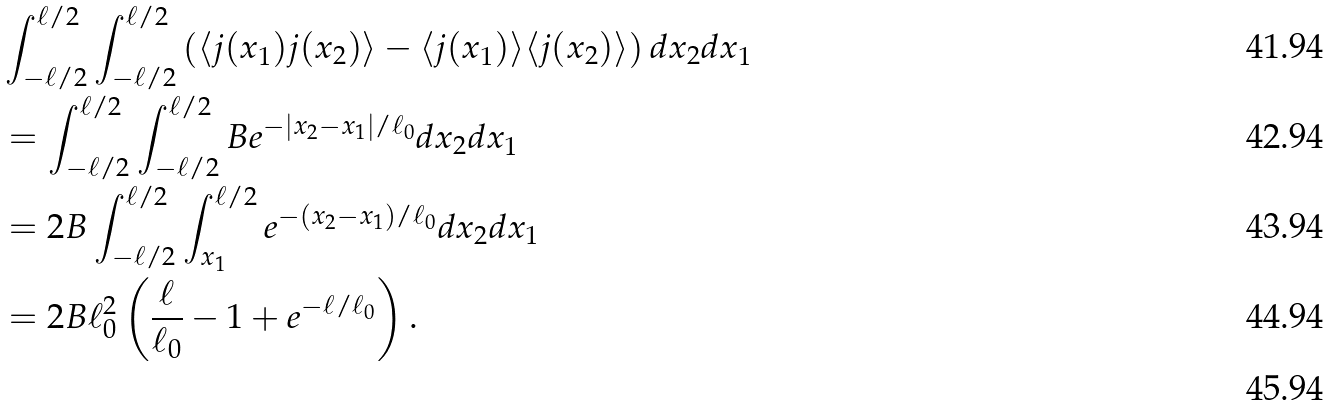Convert formula to latex. <formula><loc_0><loc_0><loc_500><loc_500>& \int _ { - \ell / 2 } ^ { \ell / 2 } \int _ { - \ell / 2 } ^ { \ell / 2 } \left ( \langle j ( x _ { 1 } ) j ( x _ { 2 } ) \rangle - \langle j ( x _ { 1 } ) \rangle \langle j ( x _ { 2 } ) \rangle \right ) d x _ { 2 } d x _ { 1 } \\ & = \int _ { - \ell / 2 } ^ { \ell / 2 } \int _ { - \ell / 2 } ^ { \ell / 2 } B e ^ { - | x _ { 2 } - x _ { 1 } | / { \ell _ { 0 } } } d x _ { 2 } d x _ { 1 } \\ & = 2 B \int _ { - \ell / 2 } ^ { \ell / 2 } \int _ { x _ { 1 } } ^ { \ell / 2 } e ^ { - ( x _ { 2 } - x _ { 1 } ) / { \ell _ { 0 } } } d x _ { 2 } d x _ { 1 } \\ & = 2 B \ell _ { 0 } ^ { 2 } \left ( \frac { \ell } { \ell _ { 0 } } - 1 + e ^ { - \ell / { \ell _ { 0 } } } \right ) . \\</formula> 